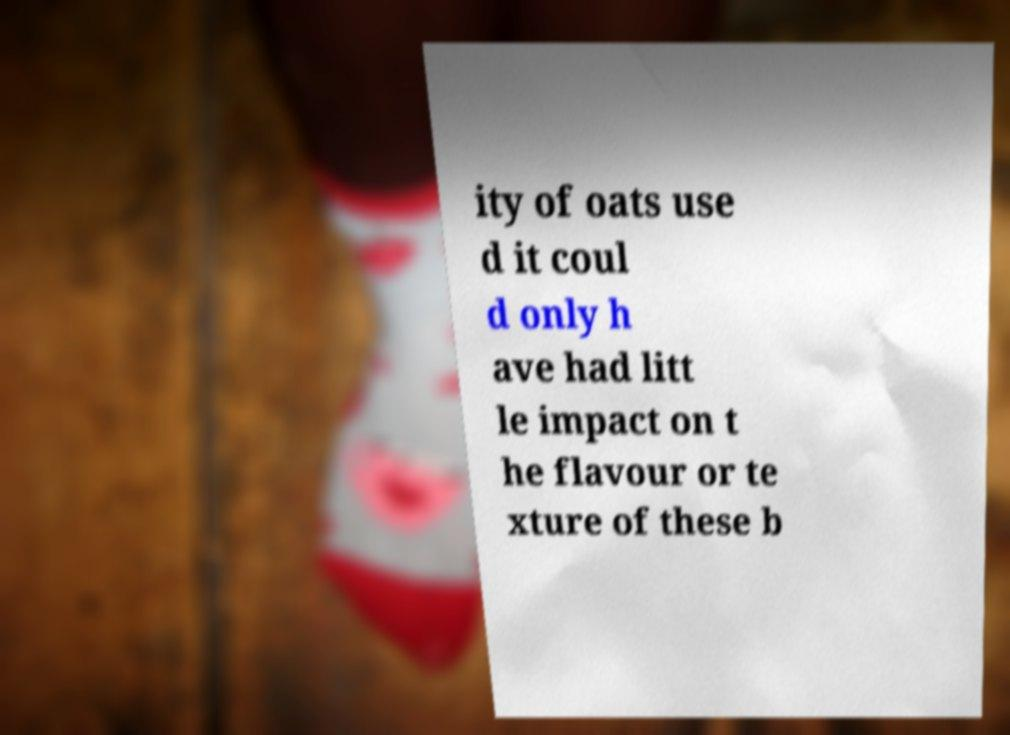I need the written content from this picture converted into text. Can you do that? ity of oats use d it coul d only h ave had litt le impact on t he flavour or te xture of these b 